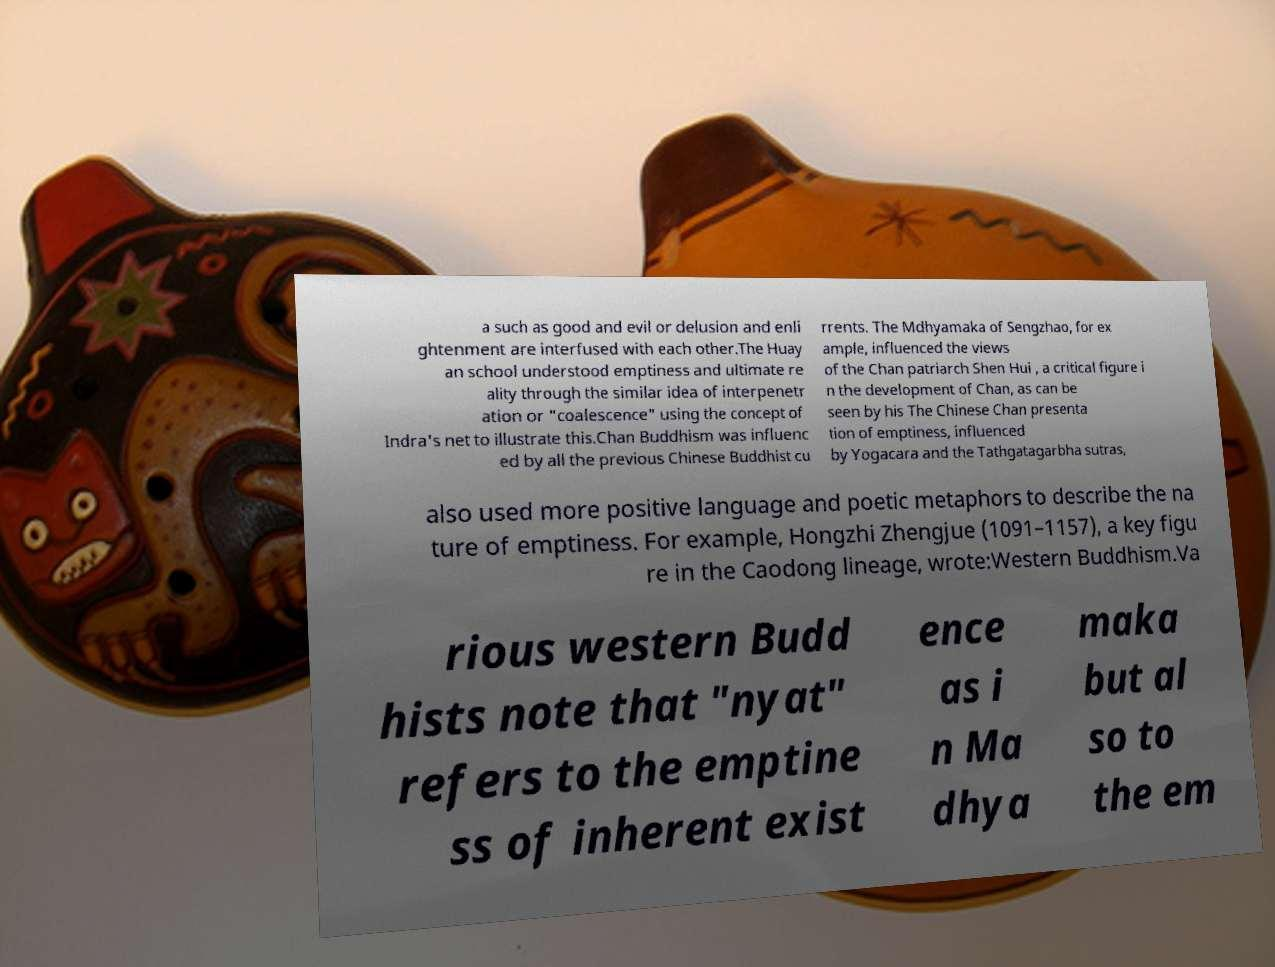Could you assist in decoding the text presented in this image and type it out clearly? a such as good and evil or delusion and enli ghtenment are interfused with each other.The Huay an school understood emptiness and ultimate re ality through the similar idea of interpenetr ation or "coalescence" using the concept of Indra's net to illustrate this.Chan Buddhism was influenc ed by all the previous Chinese Buddhist cu rrents. The Mdhyamaka of Sengzhao, for ex ample, influenced the views of the Chan patriarch Shen Hui , a critical figure i n the development of Chan, as can be seen by his The Chinese Chan presenta tion of emptiness, influenced by Yogacara and the Tathgatagarbha sutras, also used more positive language and poetic metaphors to describe the na ture of emptiness. For example, Hongzhi Zhengjue (1091–1157), a key figu re in the Caodong lineage, wrote:Western Buddhism.Va rious western Budd hists note that "nyat" refers to the emptine ss of inherent exist ence as i n Ma dhya maka but al so to the em 